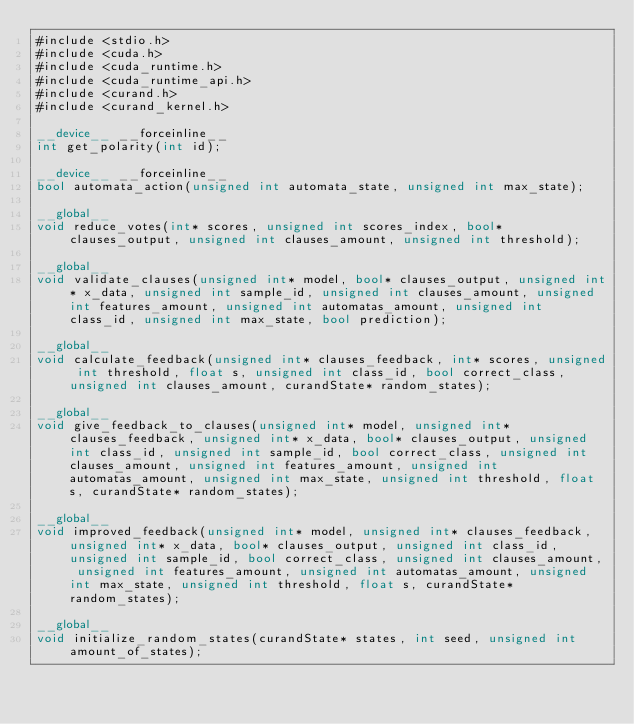Convert code to text. <code><loc_0><loc_0><loc_500><loc_500><_Cuda_>#include <stdio.h>
#include <cuda.h>
#include <cuda_runtime.h>
#include <cuda_runtime_api.h>
#include <curand.h>
#include <curand_kernel.h>

__device__ __forceinline__
int get_polarity(int id);

__device__ __forceinline__
bool automata_action(unsigned int automata_state, unsigned int max_state);

__global__
void reduce_votes(int* scores, unsigned int scores_index, bool* clauses_output, unsigned int clauses_amount, unsigned int threshold);

__global__
void validate_clauses(unsigned int* model, bool* clauses_output, unsigned int* x_data, unsigned int sample_id, unsigned int clauses_amount, unsigned int features_amount, unsigned int automatas_amount, unsigned int class_id, unsigned int max_state, bool prediction);

__global__ 
void calculate_feedback(unsigned int* clauses_feedback, int* scores, unsigned int threshold, float s, unsigned int class_id, bool correct_class, unsigned int clauses_amount, curandState* random_states); 

__global__
void give_feedback_to_clauses(unsigned int* model, unsigned int* clauses_feedback, unsigned int* x_data, bool* clauses_output, unsigned int class_id, unsigned int sample_id, bool correct_class, unsigned int clauses_amount, unsigned int features_amount, unsigned int automatas_amount, unsigned int max_state, unsigned int threshold, float s, curandState* random_states);

__global__
void improved_feedback(unsigned int* model, unsigned int* clauses_feedback, unsigned int* x_data, bool* clauses_output, unsigned int class_id, unsigned int sample_id, bool correct_class, unsigned int clauses_amount, unsigned int features_amount, unsigned int automatas_amount, unsigned int max_state, unsigned int threshold, float s, curandState* random_states);

__global__
void initialize_random_states(curandState* states, int seed, unsigned int amount_of_states);

</code> 